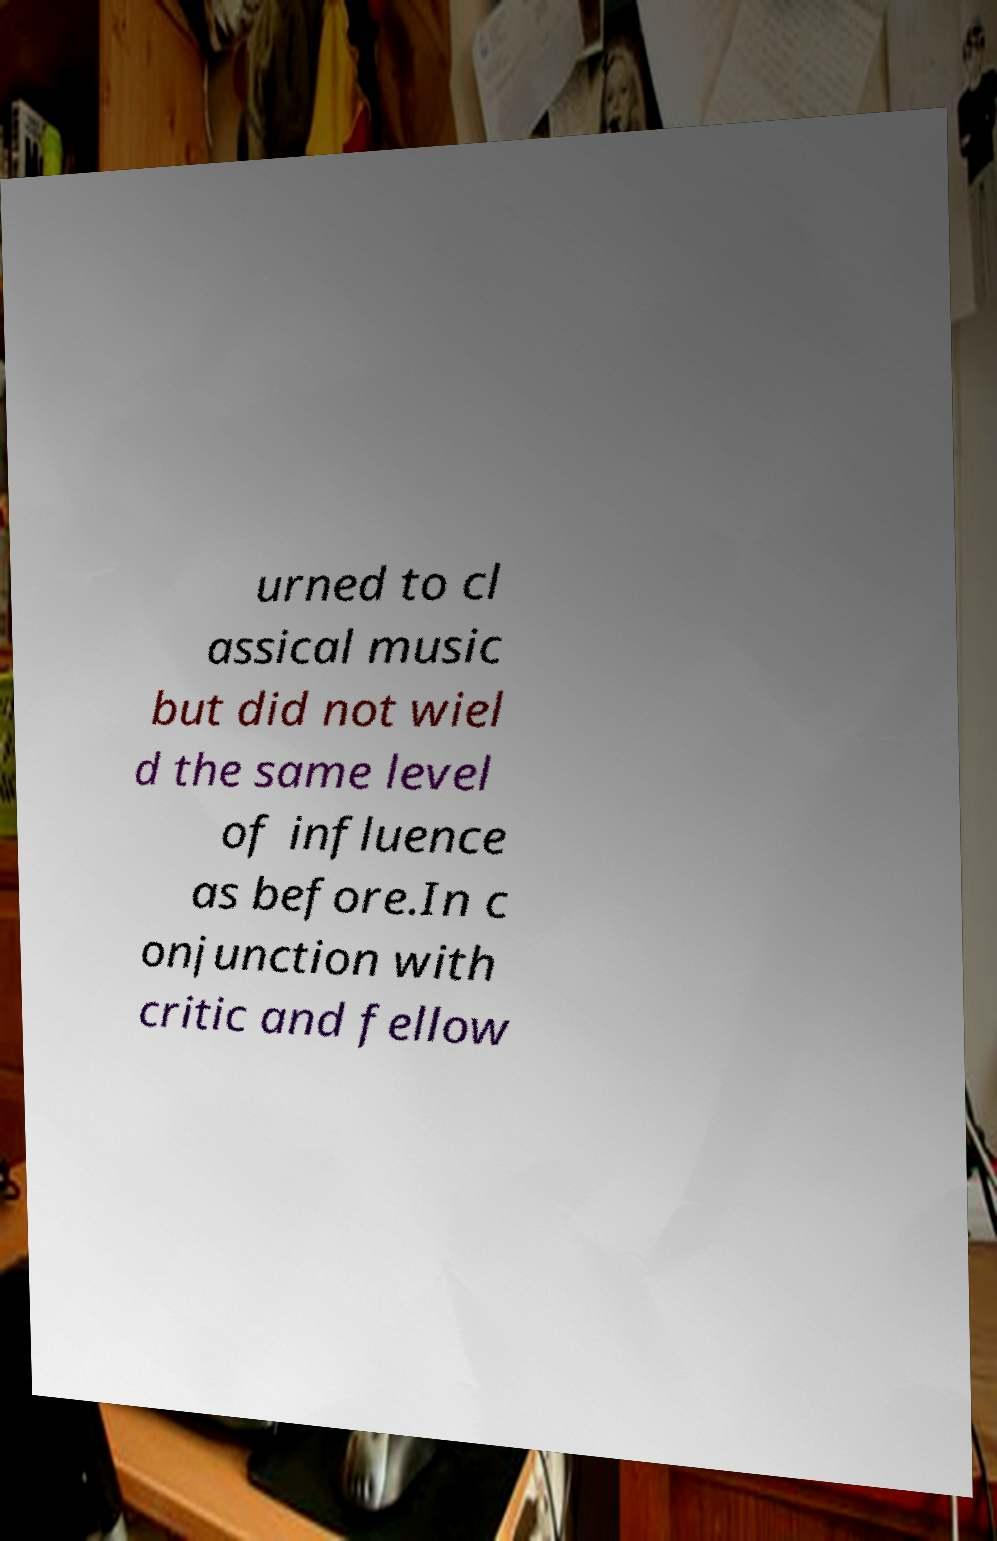There's text embedded in this image that I need extracted. Can you transcribe it verbatim? urned to cl assical music but did not wiel d the same level of influence as before.In c onjunction with critic and fellow 